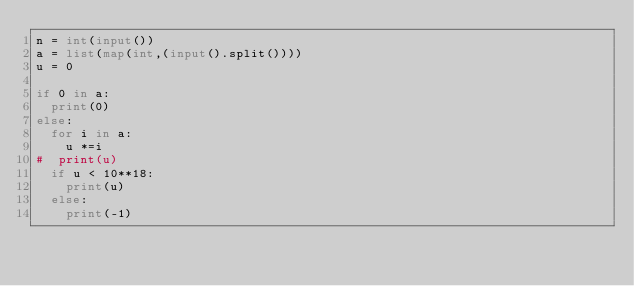Convert code to text. <code><loc_0><loc_0><loc_500><loc_500><_Python_>n = int(input())
a = list(map(int,(input().split())))
u = 0  

if 0 in a:
  print(0)
else:
  for i in a:
    u *=i
#  print(u)  
  if u < 10**18:
    print(u)
  else:
    print(-1)
    

  
  </code> 